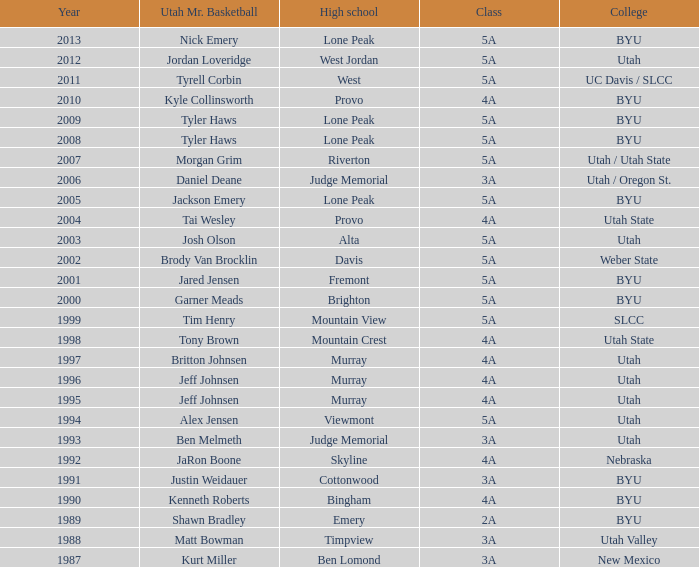Where did Tyler Haws, 2009 Utah Mr. Basketball, go to high school? Lone Peak. Would you mind parsing the complete table? {'header': ['Year', 'Utah Mr. Basketball', 'High school', 'Class', 'College'], 'rows': [['2013', 'Nick Emery', 'Lone Peak', '5A', 'BYU'], ['2012', 'Jordan Loveridge', 'West Jordan', '5A', 'Utah'], ['2011', 'Tyrell Corbin', 'West', '5A', 'UC Davis / SLCC'], ['2010', 'Kyle Collinsworth', 'Provo', '4A', 'BYU'], ['2009', 'Tyler Haws', 'Lone Peak', '5A', 'BYU'], ['2008', 'Tyler Haws', 'Lone Peak', '5A', 'BYU'], ['2007', 'Morgan Grim', 'Riverton', '5A', 'Utah / Utah State'], ['2006', 'Daniel Deane', 'Judge Memorial', '3A', 'Utah / Oregon St.'], ['2005', 'Jackson Emery', 'Lone Peak', '5A', 'BYU'], ['2004', 'Tai Wesley', 'Provo', '4A', 'Utah State'], ['2003', 'Josh Olson', 'Alta', '5A', 'Utah'], ['2002', 'Brody Van Brocklin', 'Davis', '5A', 'Weber State'], ['2001', 'Jared Jensen', 'Fremont', '5A', 'BYU'], ['2000', 'Garner Meads', 'Brighton', '5A', 'BYU'], ['1999', 'Tim Henry', 'Mountain View', '5A', 'SLCC'], ['1998', 'Tony Brown', 'Mountain Crest', '4A', 'Utah State'], ['1997', 'Britton Johnsen', 'Murray', '4A', 'Utah'], ['1996', 'Jeff Johnsen', 'Murray', '4A', 'Utah'], ['1995', 'Jeff Johnsen', 'Murray', '4A', 'Utah'], ['1994', 'Alex Jensen', 'Viewmont', '5A', 'Utah'], ['1993', 'Ben Melmeth', 'Judge Memorial', '3A', 'Utah'], ['1992', 'JaRon Boone', 'Skyline', '4A', 'Nebraska'], ['1991', 'Justin Weidauer', 'Cottonwood', '3A', 'BYU'], ['1990', 'Kenneth Roberts', 'Bingham', '4A', 'BYU'], ['1989', 'Shawn Bradley', 'Emery', '2A', 'BYU'], ['1988', 'Matt Bowman', 'Timpview', '3A', 'Utah Valley'], ['1987', 'Kurt Miller', 'Ben Lomond', '3A', 'New Mexico']]} 